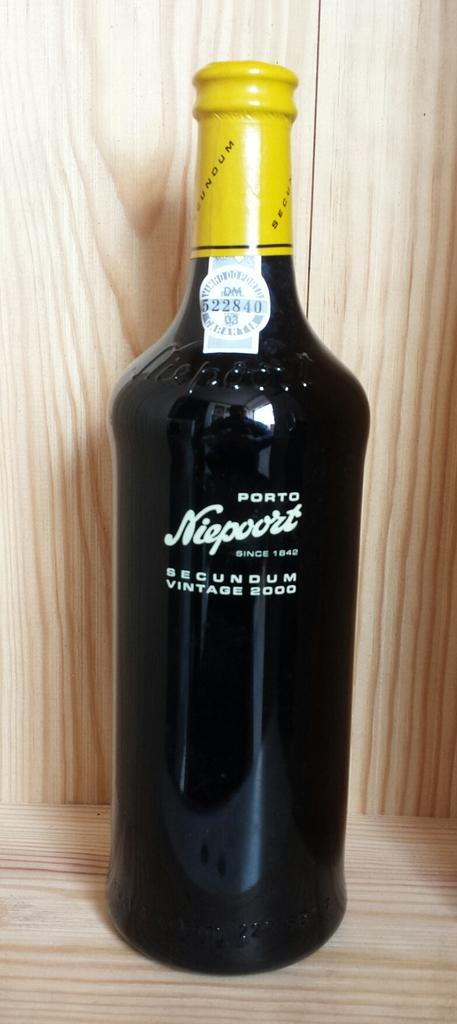<image>
Offer a succinct explanation of the picture presented. A wine is in a bottle that says it is from 2000. 